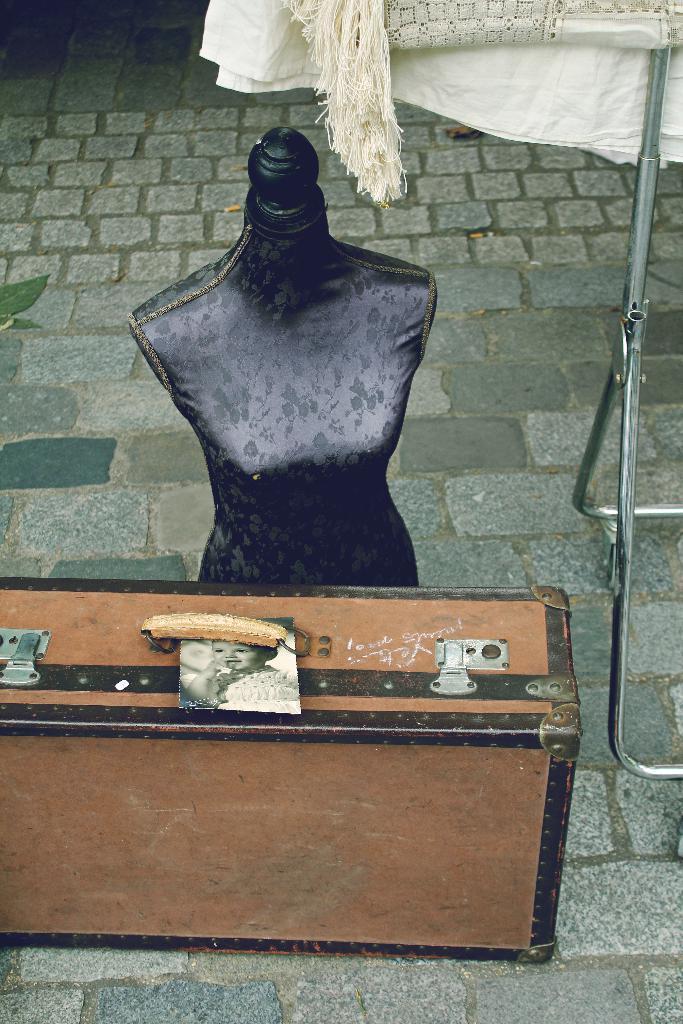How would you summarize this image in a sentence or two? In this image i can see a toy which is of black color dress which is on the floor. 